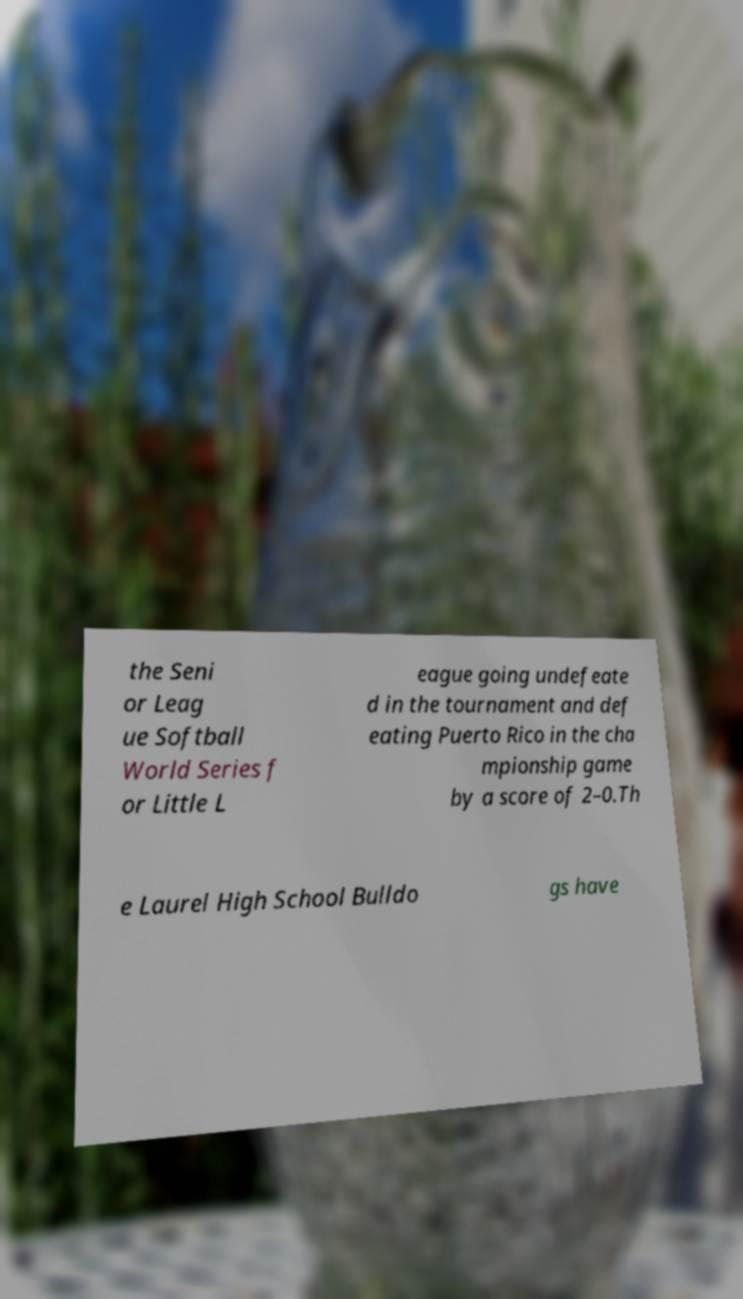Could you extract and type out the text from this image? the Seni or Leag ue Softball World Series f or Little L eague going undefeate d in the tournament and def eating Puerto Rico in the cha mpionship game by a score of 2–0.Th e Laurel High School Bulldo gs have 